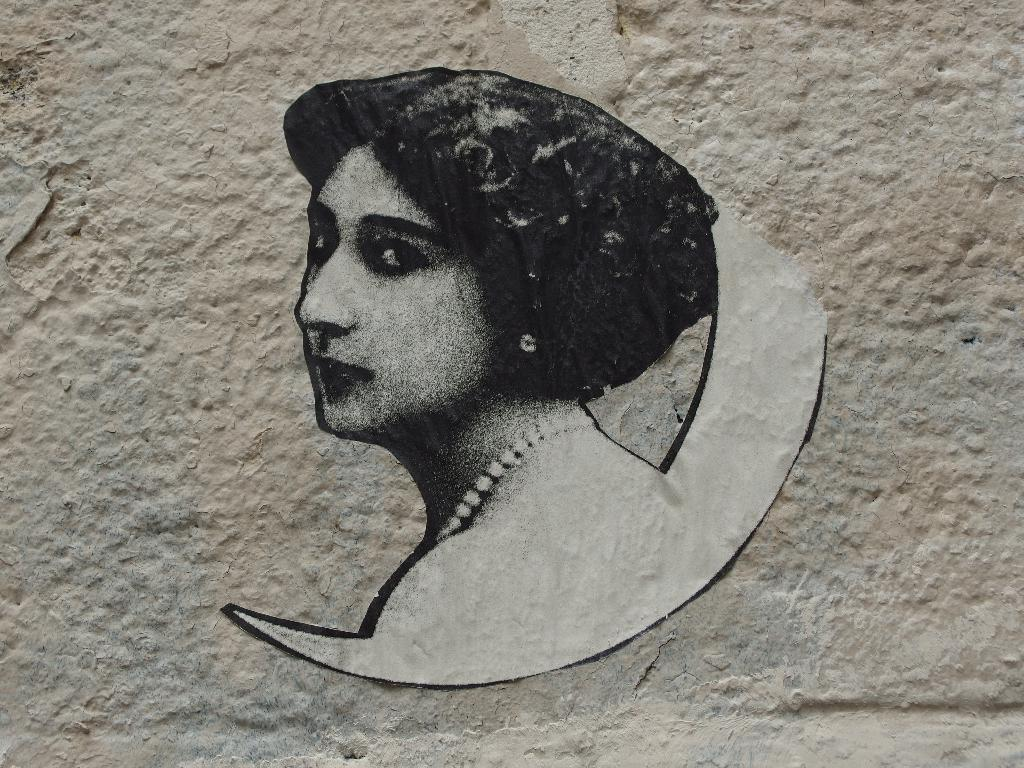What is the main subject of the image? The main subject of the image is a woman's photo. Where is the photo located in the image? The photo is placed on a wall. What type of scissors are being used to cut the coach's dinner in the image? There is no coach or dinner present in the image, and therefore no scissors or cutting activity can be observed. 